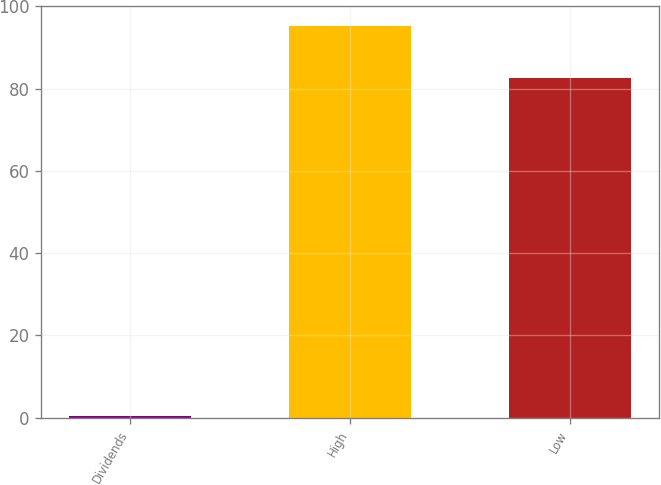Convert chart to OTSL. <chart><loc_0><loc_0><loc_500><loc_500><bar_chart><fcel>Dividends<fcel>High<fcel>Low<nl><fcel>0.46<fcel>95.24<fcel>82.49<nl></chart> 